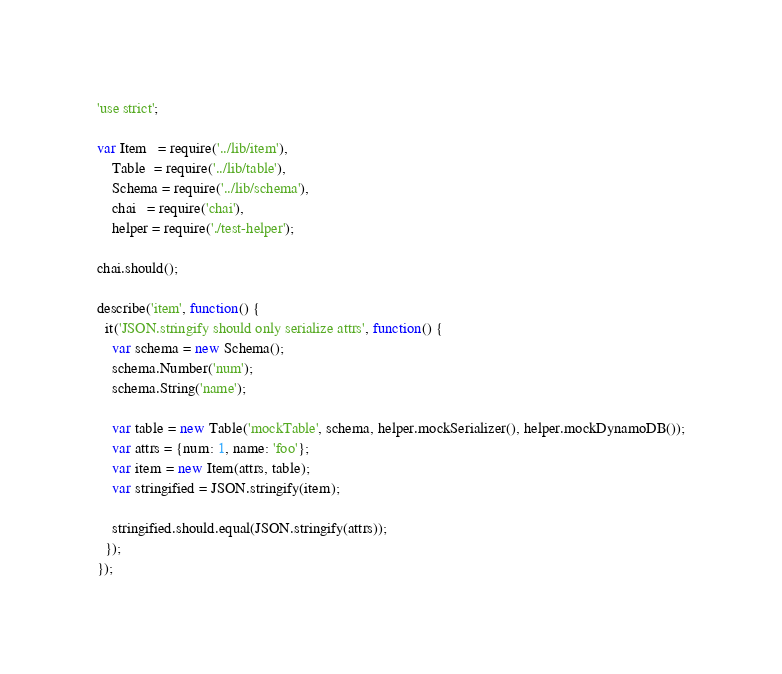<code> <loc_0><loc_0><loc_500><loc_500><_JavaScript_>'use strict';

var Item   = require('../lib/item'),
    Table  = require('../lib/table'),
    Schema = require('../lib/schema'),
    chai   = require('chai'),
    helper = require('./test-helper');

chai.should();

describe('item', function() {
  it('JSON.stringify should only serialize attrs', function() {
    var schema = new Schema();
    schema.Number('num');
    schema.String('name');

    var table = new Table('mockTable', schema, helper.mockSerializer(), helper.mockDynamoDB());
    var attrs = {num: 1, name: 'foo'};
    var item = new Item(attrs, table);
    var stringified = JSON.stringify(item);

    stringified.should.equal(JSON.stringify(attrs));
  });
});
</code> 